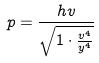<formula> <loc_0><loc_0><loc_500><loc_500>p = \frac { h v } { \sqrt { 1 \cdot \frac { v ^ { 4 } } { y ^ { 4 } } } }</formula> 